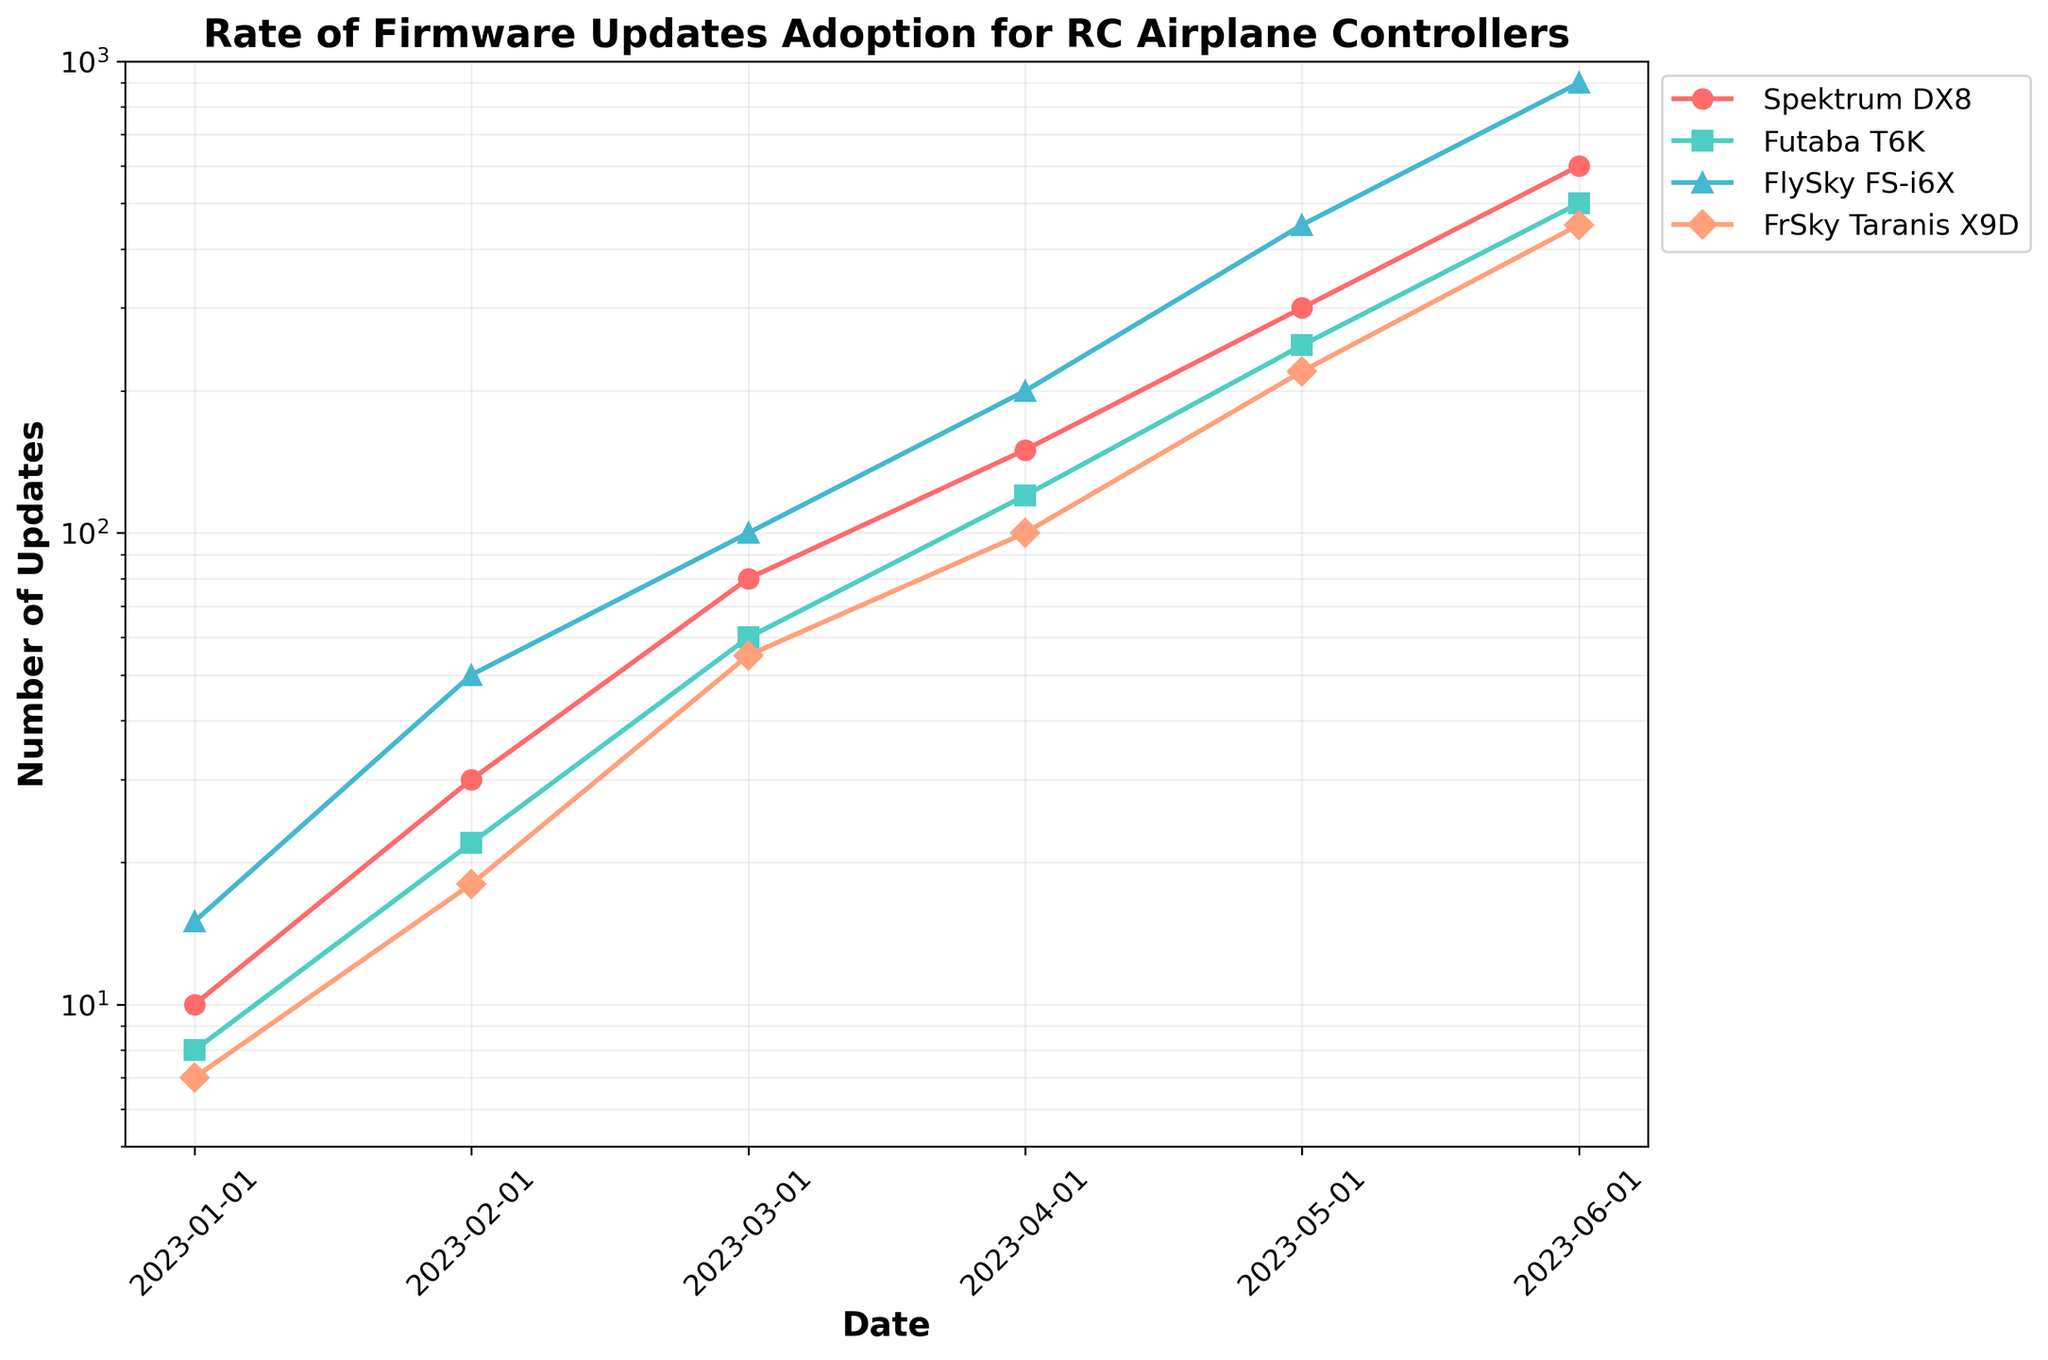What's the title of the plot? The title is displayed at the top center of the plot and describes what the plot is about.
Answer: Rate of Firmware Updates Adoption for RC Airplane Controllers How many controllers are being compared in the plot? To find the number of controllers, count the number of lines in the legend. Each line represents a different controller model.
Answer: Four Which controller had the highest number of updates in June 2023? Look at the data points on the plot for June 2023 and compare the values of each controller. The controller with the highest point on the y-axis is the one with the most updates.
Answer: FlySky FS-i6X Between which two months did the FlySky FS-i6X see the largest increase in firmware updates? To find this, compare the difference in the number of updates between consecutive months for FlySky FS-i6X by referring to the y-axis values. The largest increase will be the largest difference between two points.
Answer: May and June 2023 What is the overall trend for all controllers from January to June 2023? Observe the direction of all lines from January to June 2023. An upward trend suggests increasing updates over time.
Answer: Increasing What is the approximate range of the number of updates for Futaba T6K in the period shown? The range is found by identifying the minimum and maximum values for Futaba T6K between January and June 2023, then calculating the difference.
Answer: 8 to 500 How does the rate of updates for Spektrum DX8 in March 2023 compare to Futaba T6K in the same month? Compare the y-axis values for Spektrum DX8 and Futaba T6K in March 2023. Check which is higher and by how much.
Answer: Spektrum DX8 has more updates What can be inferred about the firmware update adoption for FrSky Taranis X9D between January and June 2023? Examine the plot line for FrSky Taranis X9D from January to June 2023, noting its progress. The trend will indicate whether updates are increasing, decreasing, or stable.
Answer: Increasing Which controller had the second highest number of updates in April 2023? Identify the points for April 2023 and determine the position of the controllers based on their y-axis values. The second highest is the next highest point after the maximum.
Answer: Futaba T6K 